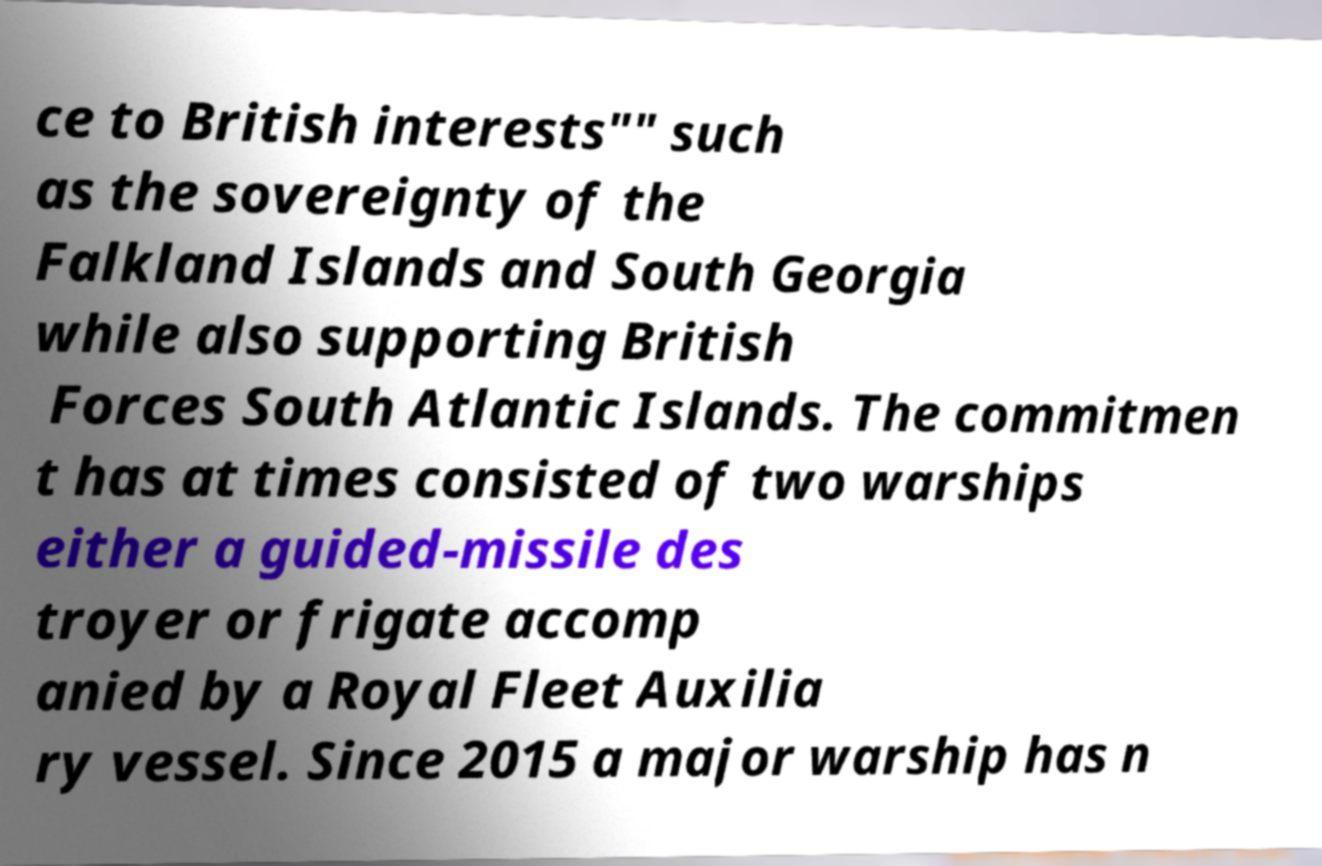Can you read and provide the text displayed in the image?This photo seems to have some interesting text. Can you extract and type it out for me? ce to British interests"" such as the sovereignty of the Falkland Islands and South Georgia while also supporting British Forces South Atlantic Islands. The commitmen t has at times consisted of two warships either a guided-missile des troyer or frigate accomp anied by a Royal Fleet Auxilia ry vessel. Since 2015 a major warship has n 